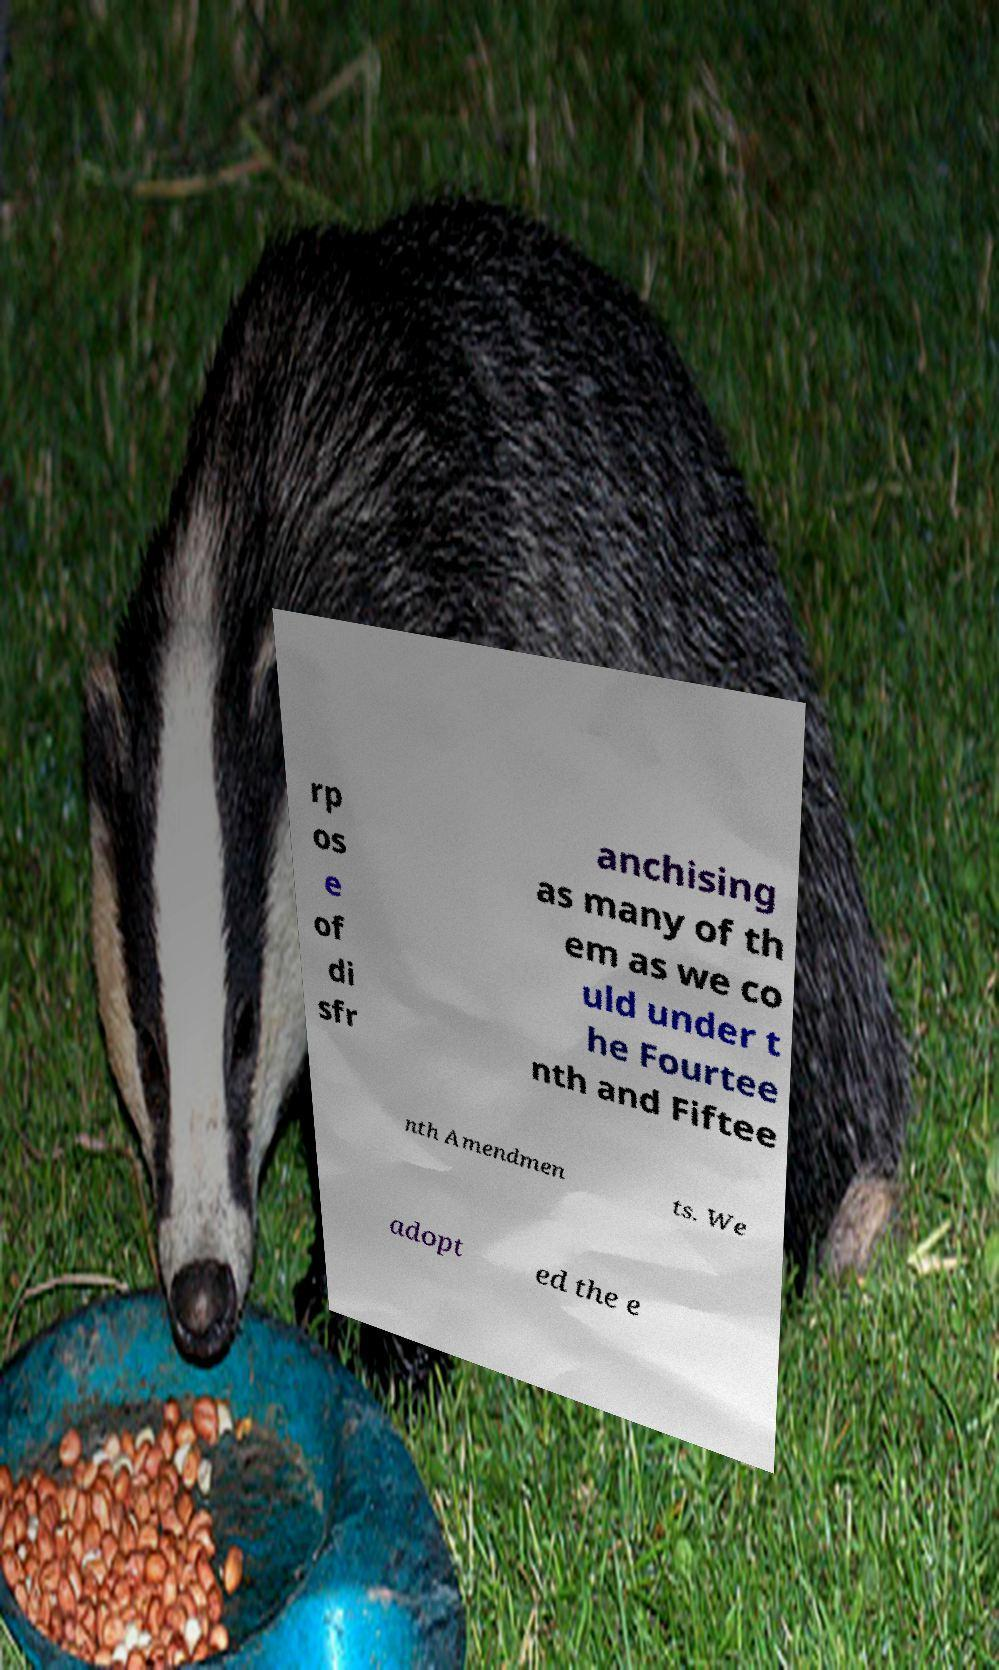Can you read and provide the text displayed in the image?This photo seems to have some interesting text. Can you extract and type it out for me? rp os e of di sfr anchising as many of th em as we co uld under t he Fourtee nth and Fiftee nth Amendmen ts. We adopt ed the e 